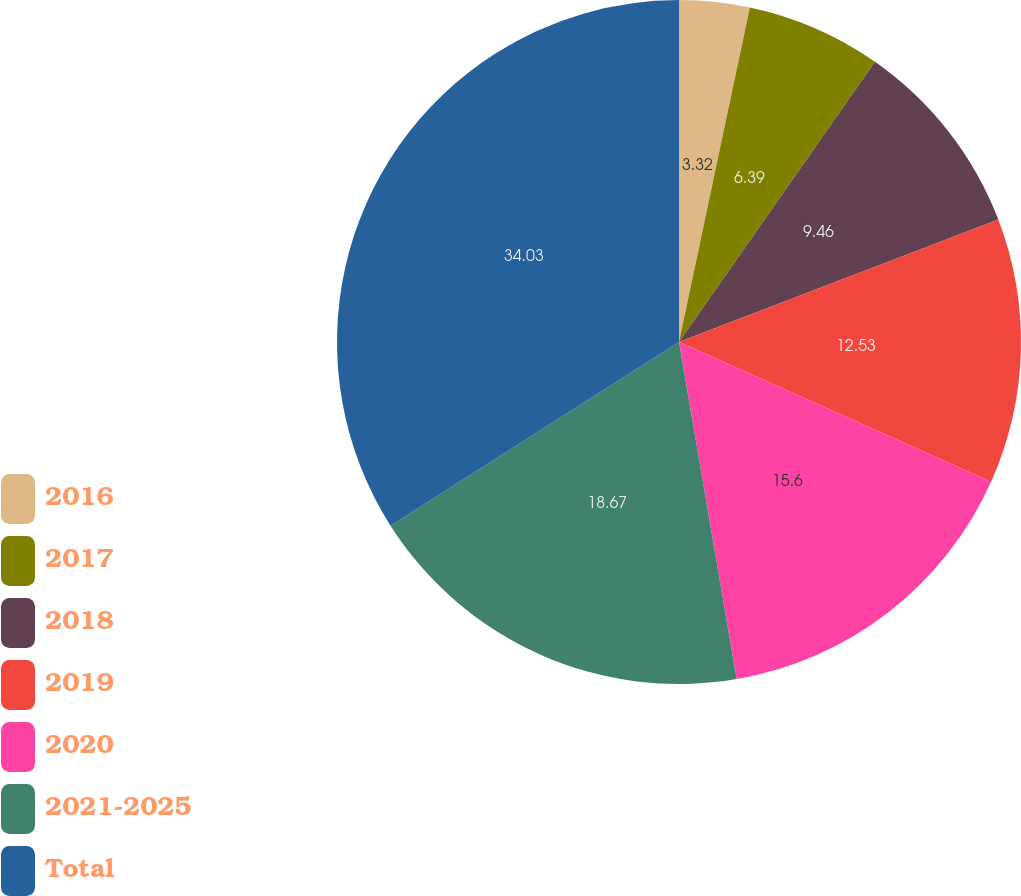Convert chart. <chart><loc_0><loc_0><loc_500><loc_500><pie_chart><fcel>2016<fcel>2017<fcel>2018<fcel>2019<fcel>2020<fcel>2021-2025<fcel>Total<nl><fcel>3.32%<fcel>6.39%<fcel>9.46%<fcel>12.53%<fcel>15.6%<fcel>18.67%<fcel>34.02%<nl></chart> 